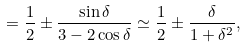Convert formula to latex. <formula><loc_0><loc_0><loc_500><loc_500>= \frac { 1 } { 2 } \pm \frac { \sin \delta } { 3 - 2 \cos \delta } \simeq \frac { 1 } { 2 } \pm \frac { \delta } { 1 + \delta ^ { 2 } } ,</formula> 